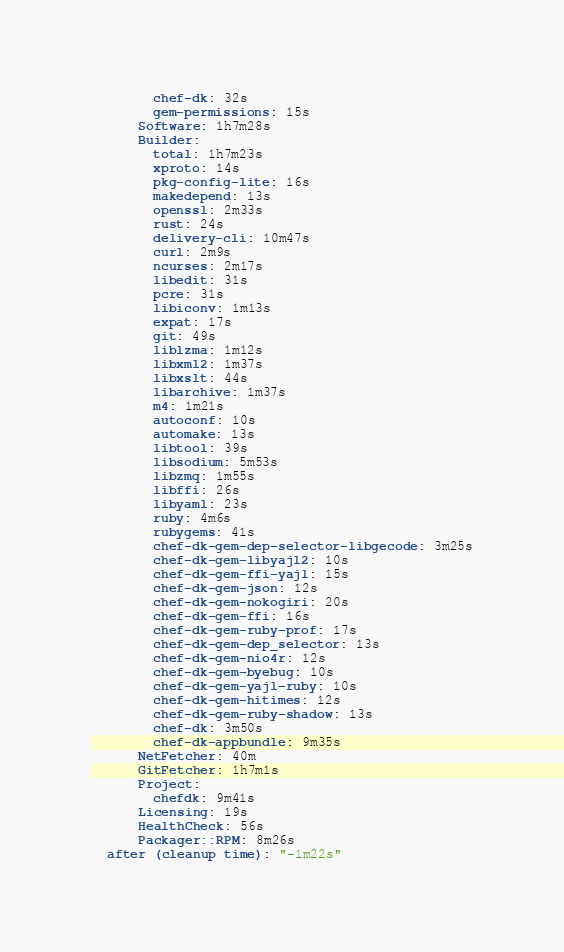Convert code to text. <code><loc_0><loc_0><loc_500><loc_500><_YAML_>        chef-dk: 32s
        gem-permissions: 15s
      Software: 1h7m28s
      Builder:
        total: 1h7m23s
        xproto: 14s
        pkg-config-lite: 16s
        makedepend: 13s
        openssl: 2m33s
        rust: 24s
        delivery-cli: 10m47s
        curl: 2m9s
        ncurses: 2m17s
        libedit: 31s
        pcre: 31s
        libiconv: 1m13s
        expat: 17s
        git: 49s
        liblzma: 1m12s
        libxml2: 1m37s
        libxslt: 44s
        libarchive: 1m37s
        m4: 1m21s
        autoconf: 10s
        automake: 13s
        libtool: 39s
        libsodium: 5m53s
        libzmq: 1m55s
        libffi: 26s
        libyaml: 23s
        ruby: 4m6s
        rubygems: 41s
        chef-dk-gem-dep-selector-libgecode: 3m25s
        chef-dk-gem-libyajl2: 10s
        chef-dk-gem-ffi-yajl: 15s
        chef-dk-gem-json: 12s
        chef-dk-gem-nokogiri: 20s
        chef-dk-gem-ffi: 16s
        chef-dk-gem-ruby-prof: 17s
        chef-dk-gem-dep_selector: 13s
        chef-dk-gem-nio4r: 12s
        chef-dk-gem-byebug: 10s
        chef-dk-gem-yajl-ruby: 10s
        chef-dk-gem-hitimes: 12s
        chef-dk-gem-ruby-shadow: 13s
        chef-dk: 3m50s
        chef-dk-appbundle: 9m35s
      NetFetcher: 40m
      GitFetcher: 1h7m1s
      Project:
        chefdk: 9m41s
      Licensing: 19s
      HealthCheck: 56s
      Packager::RPM: 8m26s
  after (cleanup time): "-1m22s"
</code> 